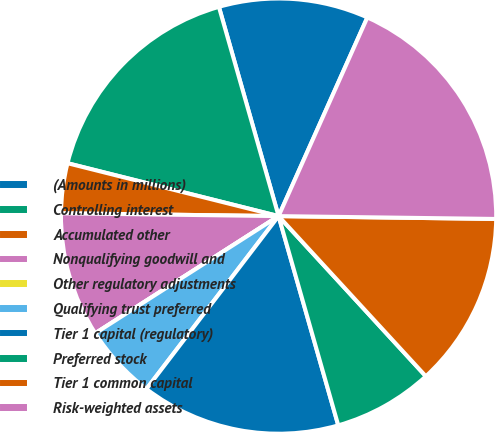Convert chart to OTSL. <chart><loc_0><loc_0><loc_500><loc_500><pie_chart><fcel>(Amounts in millions)<fcel>Controlling interest<fcel>Accumulated other<fcel>Nonqualifying goodwill and<fcel>Other regulatory adjustments<fcel>Qualifying trust preferred<fcel>Tier 1 capital (regulatory)<fcel>Preferred stock<fcel>Tier 1 common capital<fcel>Risk-weighted assets<nl><fcel>11.11%<fcel>16.67%<fcel>3.7%<fcel>9.26%<fcel>0.0%<fcel>5.56%<fcel>14.81%<fcel>7.41%<fcel>12.96%<fcel>18.52%<nl></chart> 